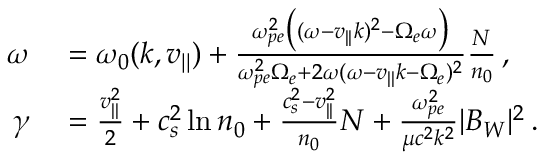Convert formula to latex. <formula><loc_0><loc_0><loc_500><loc_500>\begin{array} { r l } { \omega } & = \omega _ { 0 } ( k , v _ { | | } ) + \frac { \omega _ { p e } ^ { 2 } \left ( ( \omega - v _ { | | } k ) ^ { 2 } - \Omega _ { e } \omega \right ) } { \omega _ { p e } ^ { 2 } \Omega _ { e } + 2 \omega ( \omega - v _ { | | } k - \Omega _ { e } ) ^ { 2 } } \frac { N } { n _ { 0 } } \, , } \\ { \gamma } & = \frac { v _ { | | } ^ { 2 } } { 2 } + c _ { s } ^ { 2 } \ln n _ { 0 } + \frac { c _ { s } ^ { 2 } - v _ { | | } ^ { 2 } } { n _ { 0 } } N + \frac { \omega _ { p e } ^ { 2 } } { \mu c ^ { 2 } k ^ { 2 } } | B _ { W } | ^ { 2 } \, . } \end{array}</formula> 